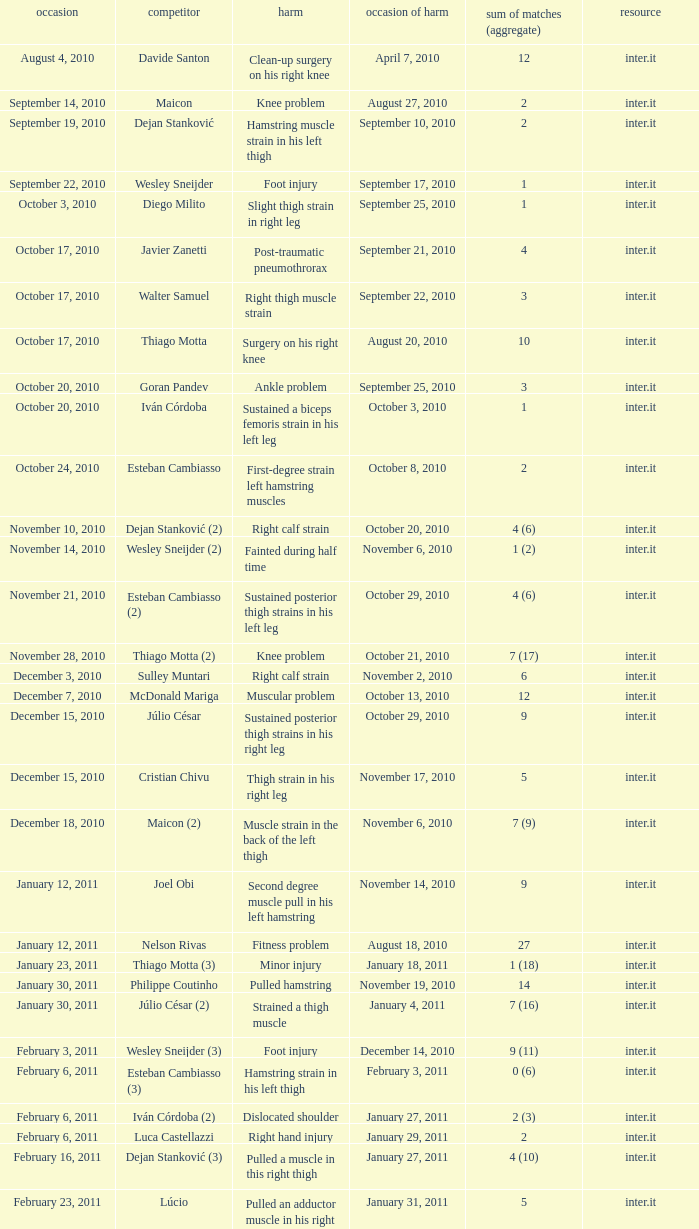What is the date of injury when the injury is sustained posterior thigh strains in his left leg? October 29, 2010. 